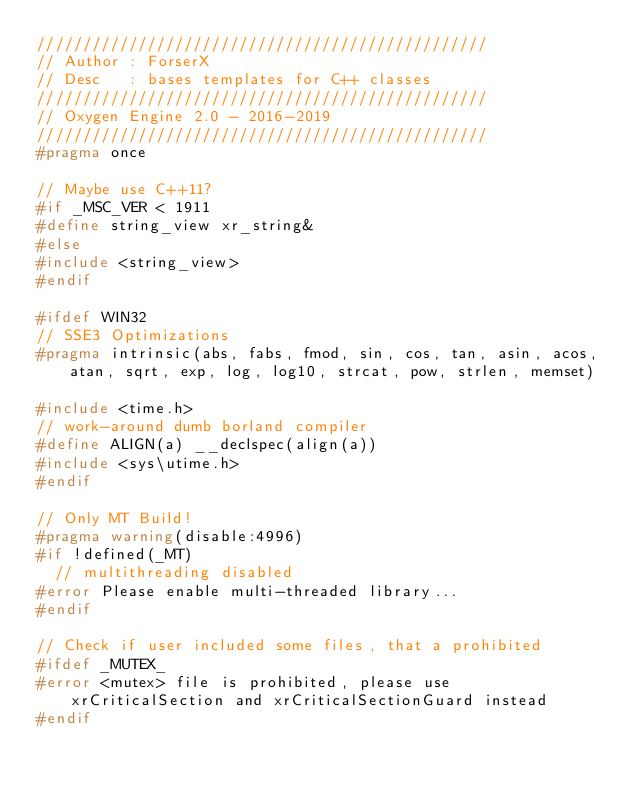Convert code to text. <code><loc_0><loc_0><loc_500><loc_500><_C_>/////////////////////////////////////////////////
// Author : ForserX
// Desc   : bases templates for C++ classes
/////////////////////////////////////////////////
// Oxygen Engine 2.0 - 2016-2019
/////////////////////////////////////////////////
#pragma once

// Maybe use C++11? 
#if _MSC_VER < 1911
#define string_view xr_string&
#else
#include <string_view>
#endif

#ifdef WIN32
// SSE3 Optimizations
#pragma intrinsic(abs, fabs, fmod, sin, cos, tan, asin, acos, atan, sqrt, exp, log, log10, strcat, pow, strlen, memset)

#include <time.h>
// work-around dumb borland compiler
#define ALIGN(a) __declspec(align(a))
#include <sys\utime.h>
#endif

// Only MT Build!
#pragma warning(disable:4996)
#if !defined(_MT)
	// multithreading disabled
#error Please enable multi-threaded library...
#endif

// Check if user included some files, that a prohibited
#ifdef _MUTEX_
#error <mutex> file is prohibited, please use xrCriticalSection and xrCriticalSectionGuard instead
#endif
</code> 